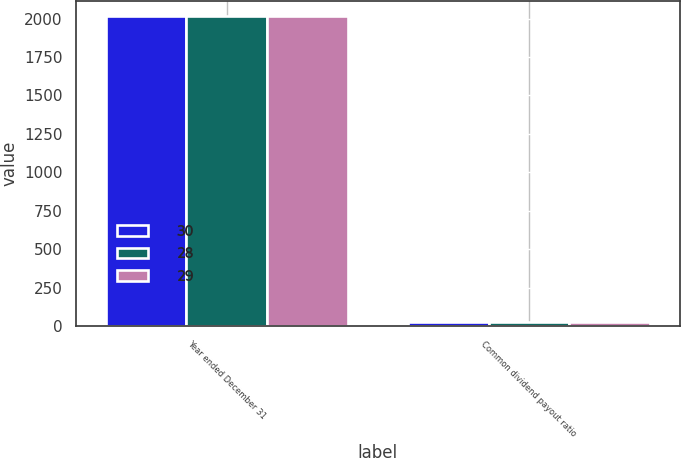Convert chart to OTSL. <chart><loc_0><loc_0><loc_500><loc_500><stacked_bar_chart><ecel><fcel>Year ended December 31<fcel>Common dividend payout ratio<nl><fcel>30<fcel>2016<fcel>30<nl><fcel>28<fcel>2015<fcel>28<nl><fcel>29<fcel>2014<fcel>29<nl></chart> 